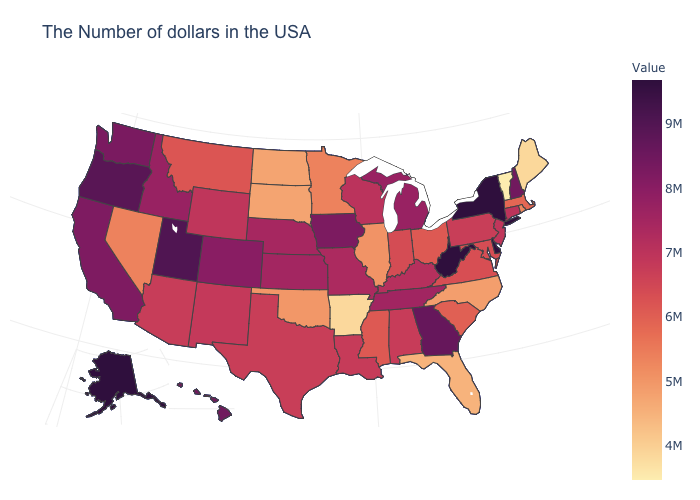Is the legend a continuous bar?
Give a very brief answer. Yes. Does Iowa have a lower value than Alaska?
Concise answer only. Yes. Is the legend a continuous bar?
Concise answer only. Yes. Among the states that border Louisiana , does Arkansas have the lowest value?
Be succinct. Yes. Does Connecticut have a lower value than New Hampshire?
Answer briefly. Yes. Among the states that border Missouri , which have the highest value?
Give a very brief answer. Iowa. 